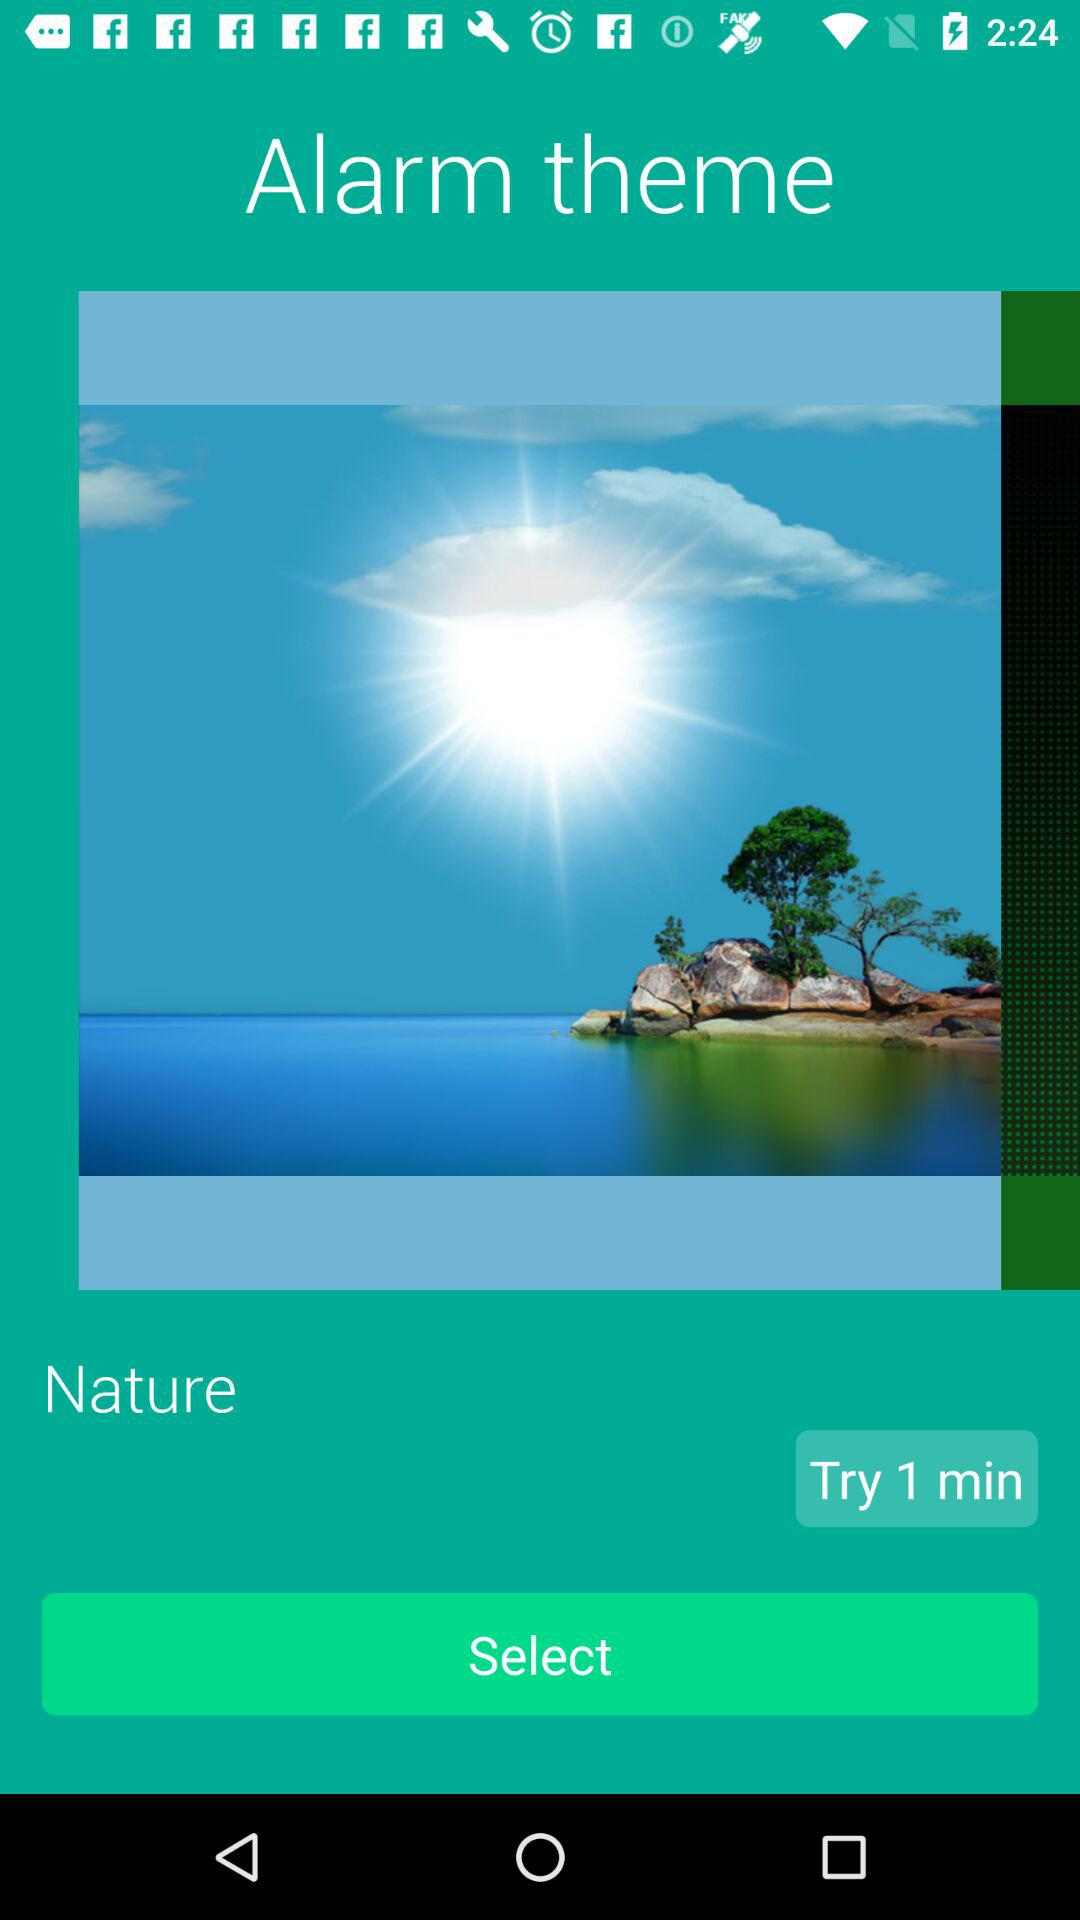What is the alarm theme? The alarm theme is "Nature". 